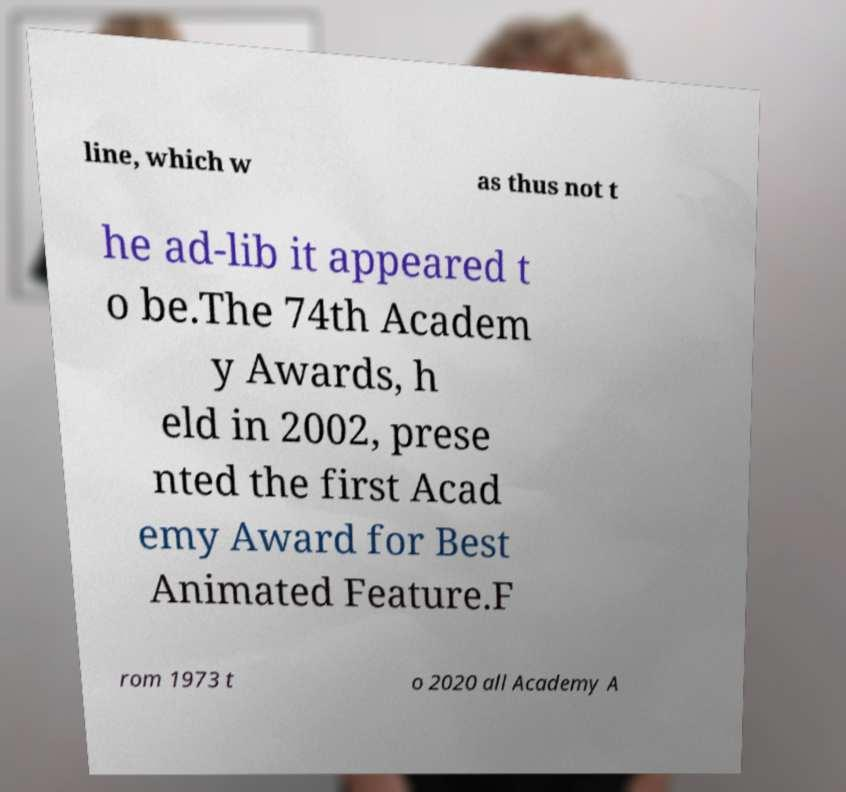For documentation purposes, I need the text within this image transcribed. Could you provide that? line, which w as thus not t he ad-lib it appeared t o be.The 74th Academ y Awards, h eld in 2002, prese nted the first Acad emy Award for Best Animated Feature.F rom 1973 t o 2020 all Academy A 